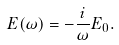Convert formula to latex. <formula><loc_0><loc_0><loc_500><loc_500>E ( \omega ) = - \frac { i } { \omega } E _ { 0 } .</formula> 